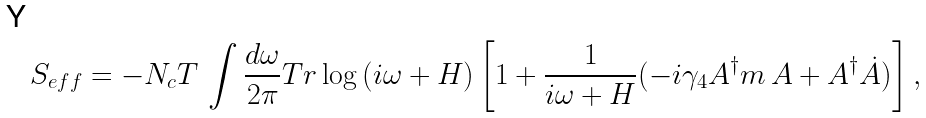Convert formula to latex. <formula><loc_0><loc_0><loc_500><loc_500>S _ { e f f } = - N _ { c } T \, \int \frac { d \omega } { 2 \pi } T r \log \, ( i \omega + H ) \left [ 1 + \frac { 1 } { i \omega + H } ( - i \gamma _ { 4 } A ^ { \dagger } m \, A + A ^ { \dagger } \dot { A } ) \right ] ,</formula> 